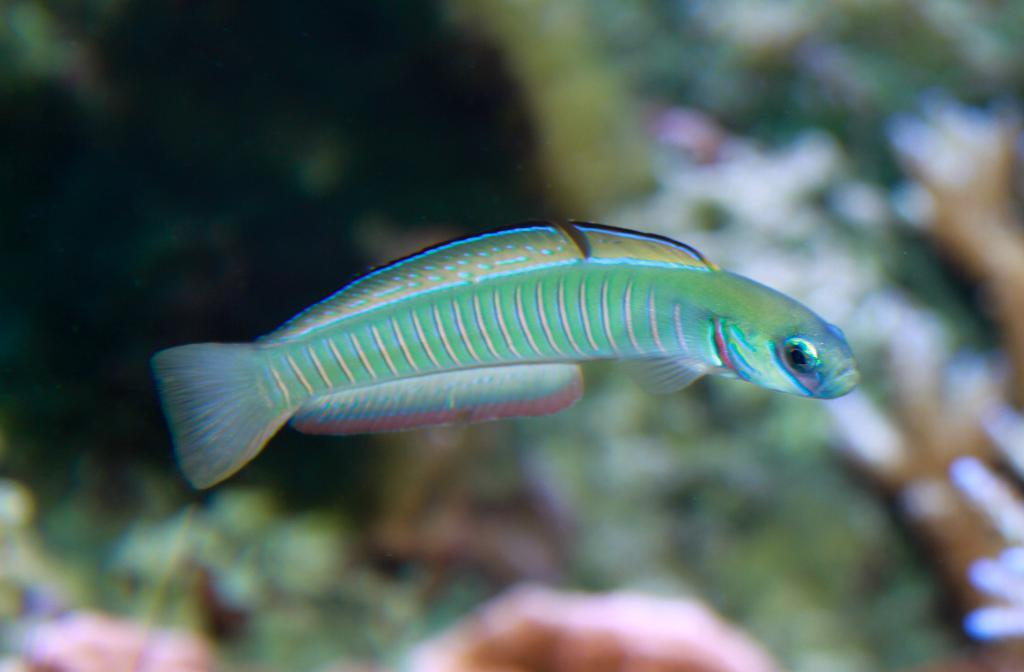What is the main subject of the image? There is a fish in the image. Can you describe the background of the image? The background of the image is blurred. What type of yarn is being used to create the fish in the image? There is no yarn present in the image; it is a photograph or illustration of a fish. How many pies are visible in the image? There are no pies present in the image; it features a fish and a blurred background. 